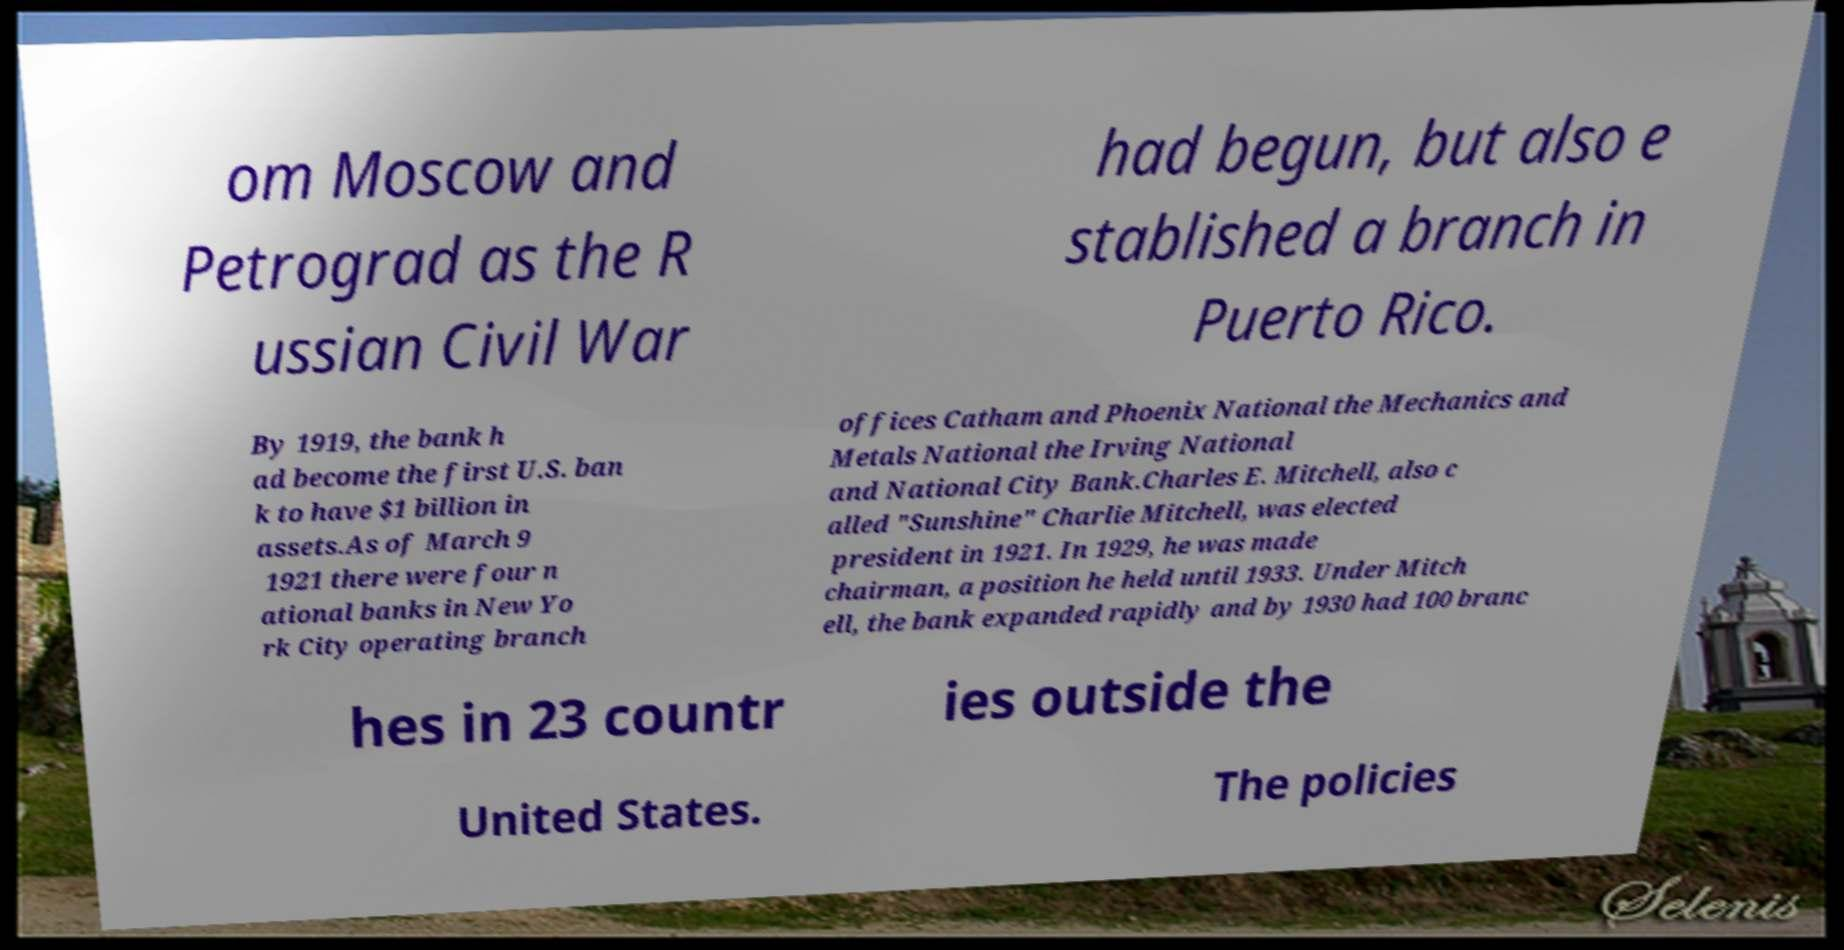What messages or text are displayed in this image? I need them in a readable, typed format. om Moscow and Petrograd as the R ussian Civil War had begun, but also e stablished a branch in Puerto Rico. By 1919, the bank h ad become the first U.S. ban k to have $1 billion in assets.As of March 9 1921 there were four n ational banks in New Yo rk City operating branch offices Catham and Phoenix National the Mechanics and Metals National the Irving National and National City Bank.Charles E. Mitchell, also c alled "Sunshine" Charlie Mitchell, was elected president in 1921. In 1929, he was made chairman, a position he held until 1933. Under Mitch ell, the bank expanded rapidly and by 1930 had 100 branc hes in 23 countr ies outside the United States. The policies 